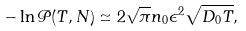Convert formula to latex. <formula><loc_0><loc_0><loc_500><loc_500>- \ln { \mathcal { P } } ( T , N ) \simeq 2 \sqrt { \pi } n _ { 0 } \epsilon ^ { 2 } \sqrt { D _ { 0 } T } ,</formula> 